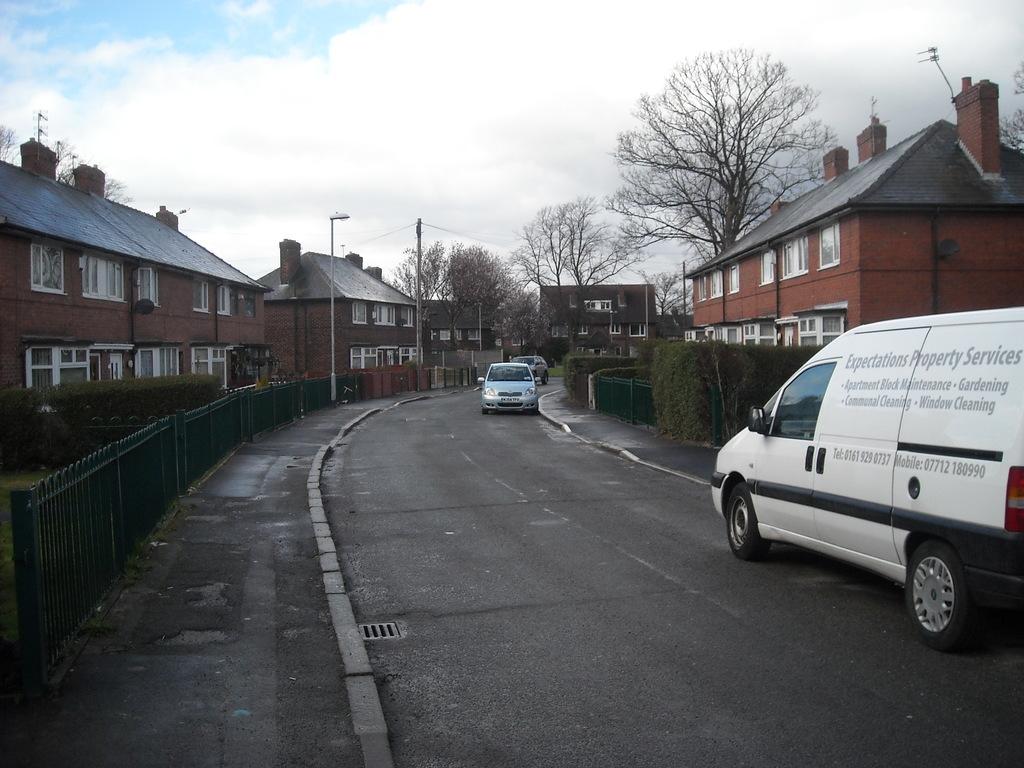What is the name of the company on the van?
Ensure brevity in your answer.  Expectations property services. 